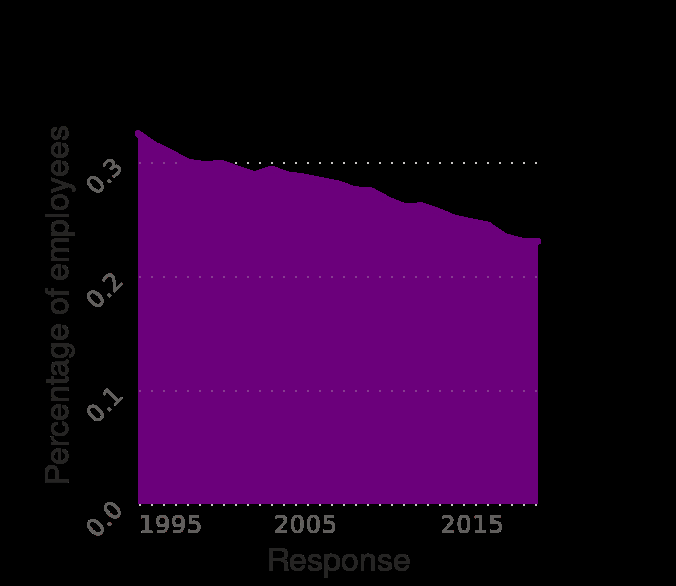<image>
What type of scale is used for the x-axis?  The x-axis uses a linear scale to represent the years from 1995 to 2019. Are employers increasingly joining trade unions?  No, the rate of employers joining trade unions is actually falling over the years. What is the general pattern observed in the usage of unions by employers? The general pattern is a gradual decrease in the rate of employers using unions or being trade union members, but with fluctuations in some years where the rate rises and then falls. 